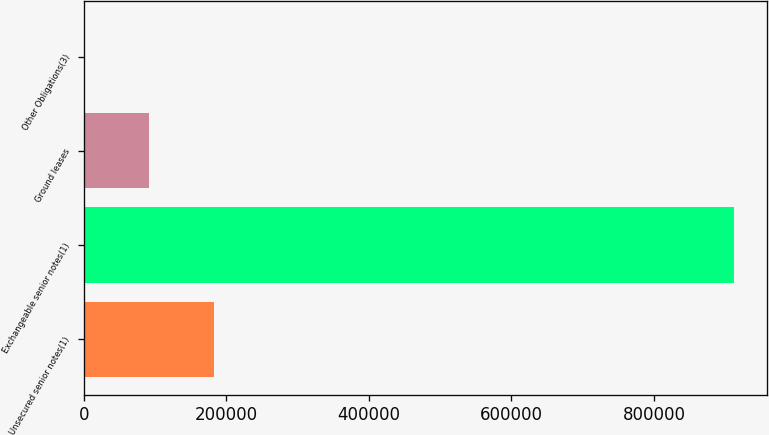Convert chart. <chart><loc_0><loc_0><loc_500><loc_500><bar_chart><fcel>Unsecured senior notes(1)<fcel>Exchangeable senior notes(1)<fcel>Ground leases<fcel>Other Obligations(3)<nl><fcel>182627<fcel>912671<fcel>91371.5<fcel>116<nl></chart> 